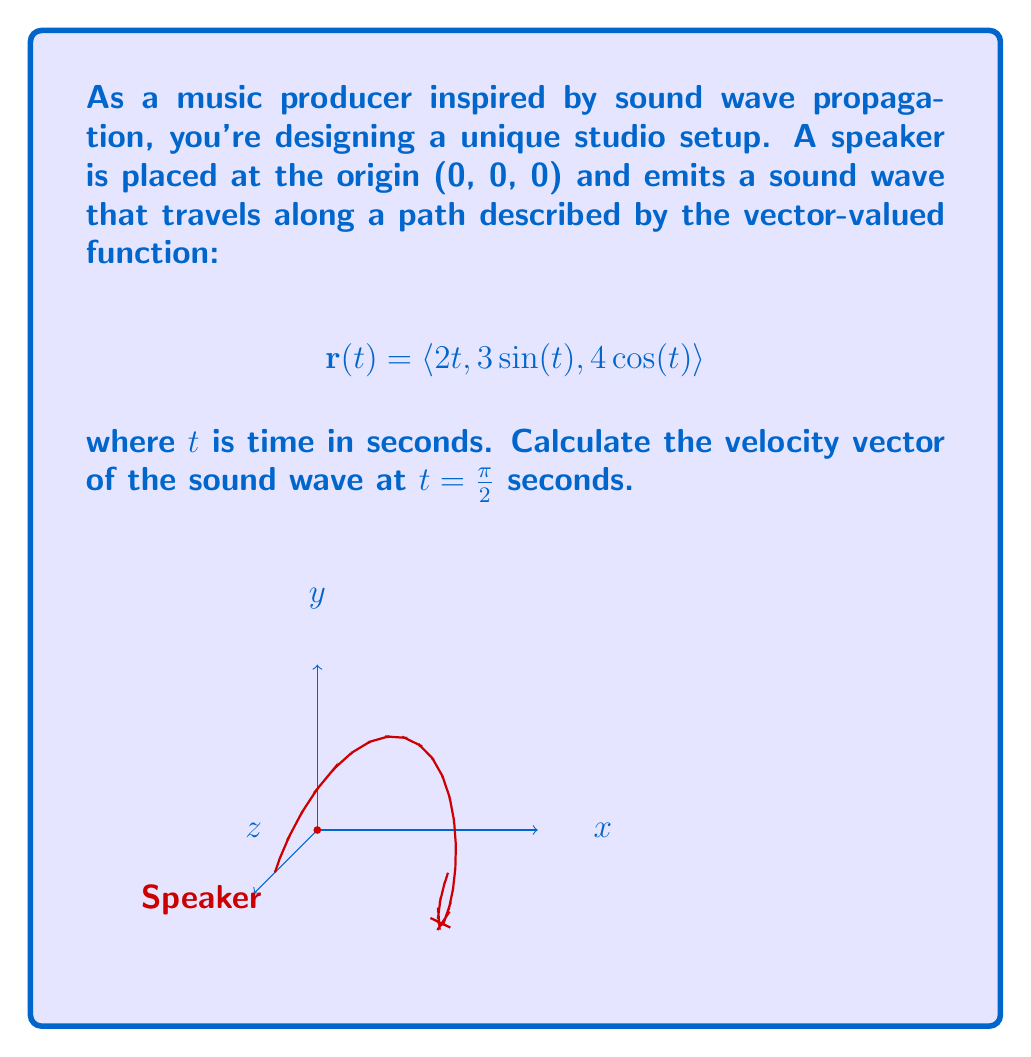Teach me how to tackle this problem. To solve this problem, we need to follow these steps:

1) The velocity vector is the derivative of the position vector with respect to time. So, we need to find $\mathbf{r}'(t)$.

2) Let's differentiate each component of $\mathbf{r}(t)$:
   
   $$\mathbf{r}(t) = \langle 2t, 3\sin(t), 4\cos(t) \rangle$$
   
   $$\mathbf{r}'(t) = \langle 2, 3\cos(t), -4\sin(t) \rangle$$

3) Now, we need to evaluate this at $t = \frac{\pi}{2}$:
   
   $$\mathbf{r}'(\frac{\pi}{2}) = \langle 2, 3\cos(\frac{\pi}{2}), -4\sin(\frac{\pi}{2}) \rangle$$

4) Recall that $\cos(\frac{\pi}{2}) = 0$ and $\sin(\frac{\pi}{2}) = 1$:
   
   $$\mathbf{r}'(\frac{\pi}{2}) = \langle 2, 3(0), -4(1) \rangle = \langle 2, 0, -4 \rangle$$

Therefore, the velocity vector at $t = \frac{\pi}{2}$ seconds is $\langle 2, 0, -4 \rangle$.
Answer: $\langle 2, 0, -4 \rangle$ 